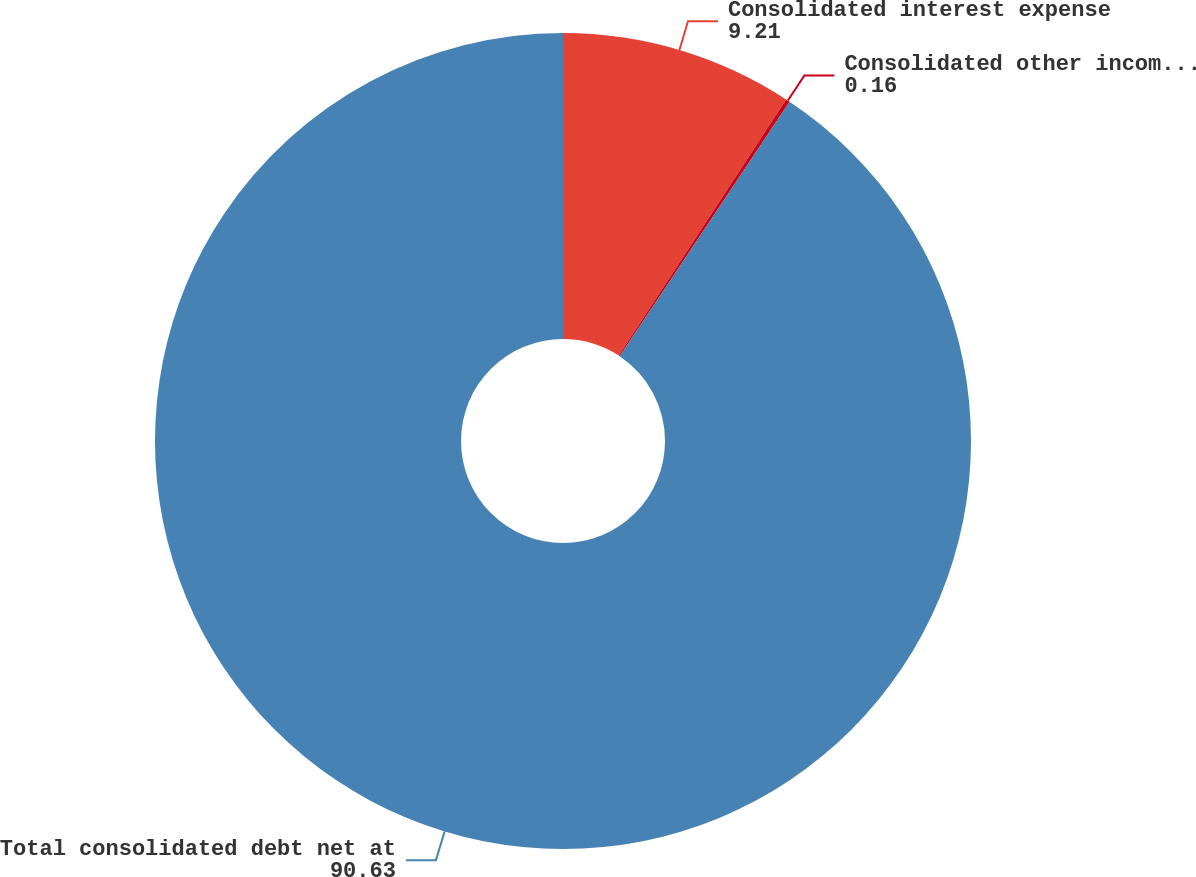Convert chart to OTSL. <chart><loc_0><loc_0><loc_500><loc_500><pie_chart><fcel>Consolidated interest expense<fcel>Consolidated other income net<fcel>Total consolidated debt net at<nl><fcel>9.21%<fcel>0.16%<fcel>90.63%<nl></chart> 